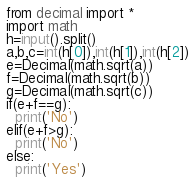Convert code to text. <code><loc_0><loc_0><loc_500><loc_500><_Python_>from decimal import *
import math
h=input().split()
a,b,c=int(h[0]),int(h[1]),int(h[2])
e=Decimal(math.sqrt(a))
f=Decimal(math.sqrt(b))
g=Decimal(math.sqrt(c))
if(e+f==g):
  print('No')
elif(e+f>g):
  print('No')
else:
  print('Yes')</code> 